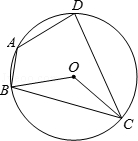Describe what you see in the figure. In the diagram, you can see a quadrilateral, specifically labeled ABCD, that is perfectly inscribed within a circle, which is centered at point O. Each vertex of the quadrilateral, points A, B, C, and D, touches the circumference of the circle. This setup suggests interesting geometrical properties such as angle and chord relationships that are typical in circles. Examining such a figure could lead to insights about the angles formed between adjacent vertices and their relation to the circle. 